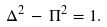<formula> <loc_0><loc_0><loc_500><loc_500>\Delta ^ { 2 } \, - \, \Pi ^ { 2 } = 1 .</formula> 